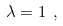Convert formula to latex. <formula><loc_0><loc_0><loc_500><loc_500>\lambda = 1 \ ,</formula> 